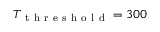<formula> <loc_0><loc_0><loc_500><loc_500>T _ { t h r e s h o l d } = 3 0 0</formula> 